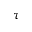Convert formula to latex. <formula><loc_0><loc_0><loc_500><loc_500>\tau</formula> 